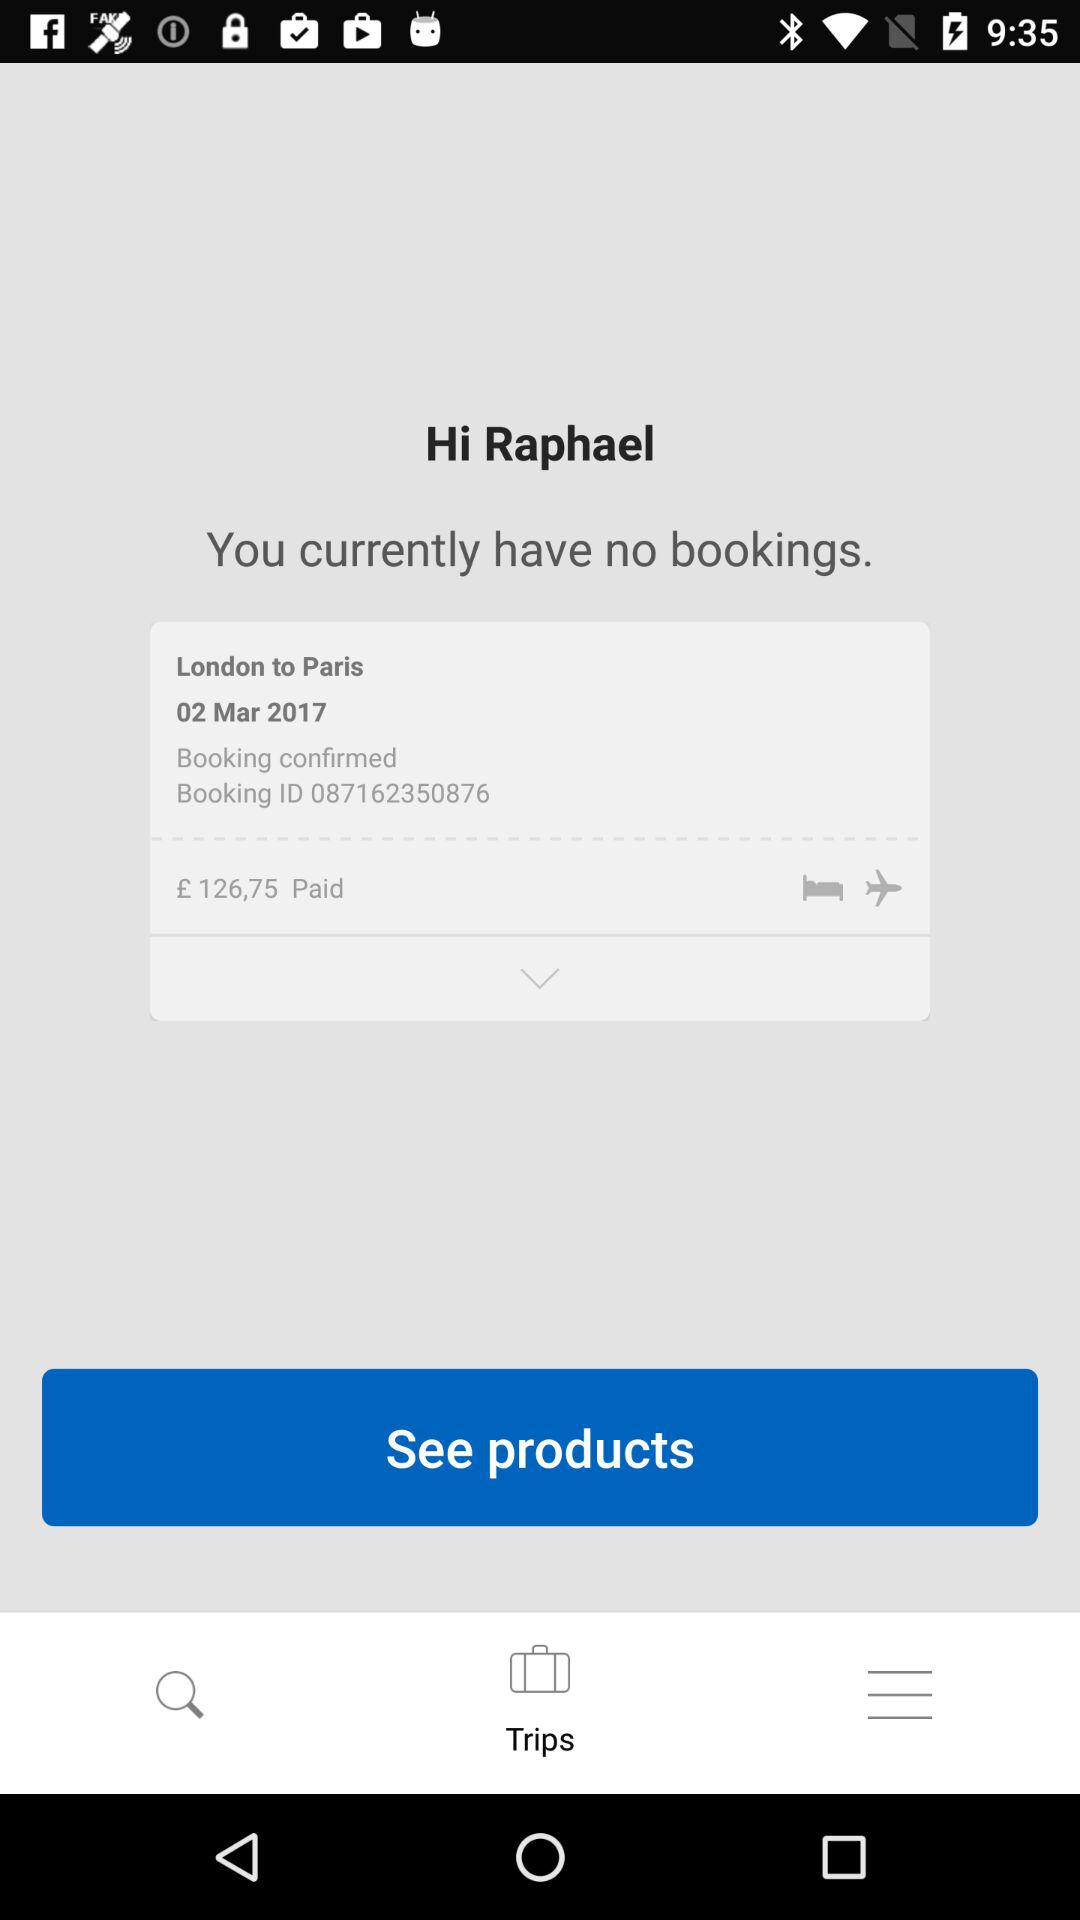What is the date on which the last booking was made? The date on which the last booking was made is March 02, 2017. 